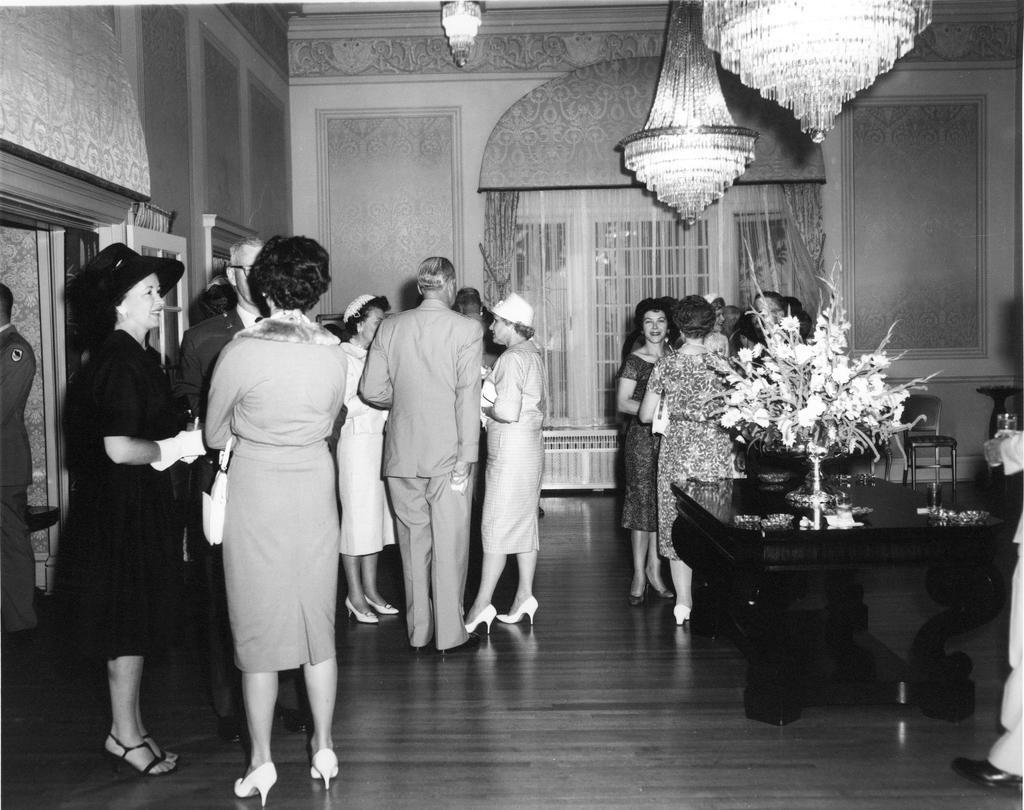Please provide a concise description of this image. This picture describes about group of people, few people wore caps, on the right side of the image we can find a flower vase and other things on the table, in the background we can find curtains, at the top of the image we can see lights and it is a black and white photography. 